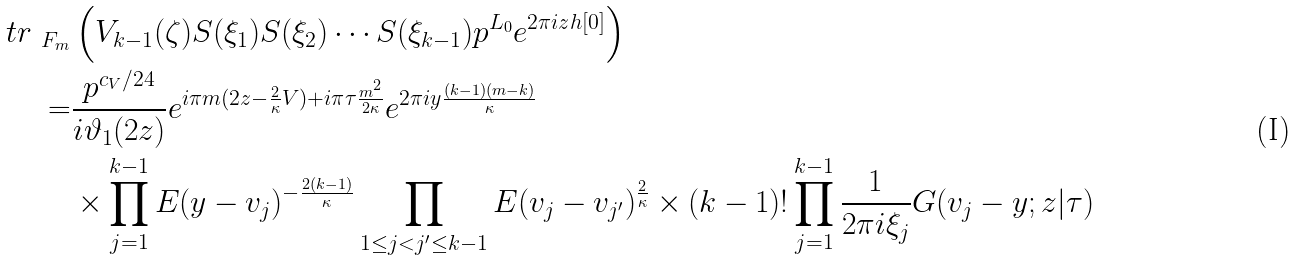<formula> <loc_0><loc_0><loc_500><loc_500>\ t r _ { \ F _ { m } } & \left ( V _ { k - 1 } ( \zeta ) S ( \xi _ { 1 } ) S ( \xi _ { 2 } ) \cdots S ( \xi _ { k - 1 } ) p ^ { L _ { 0 } } e ^ { 2 \pi i z h [ 0 ] } \right ) \\ = & \frac { p ^ { c _ { V } / 2 4 } } { i \vartheta _ { 1 } ( 2 z ) } e ^ { i \pi m ( 2 z - \frac { 2 } { \kappa } V ) + i \pi \tau \frac { m ^ { 2 } } { 2 \kappa } } e ^ { 2 \pi i y \frac { ( k - 1 ) ( m - k ) } { \kappa } } \\ & \times \prod _ { j = 1 } ^ { k - 1 } E ( y - v _ { j } ) ^ { - \frac { 2 ( k - 1 ) } { \kappa } } \prod _ { 1 \leq j < j ^ { \prime } \leq k - 1 } E ( v _ { j } - v _ { j ^ { \prime } } ) ^ { \frac { 2 } { \kappa } } \times ( k - 1 ) ! \prod _ { j = 1 } ^ { k - 1 } \frac { 1 } { 2 \pi i \xi _ { j } } G ( v _ { j } - y ; z | \tau )</formula> 